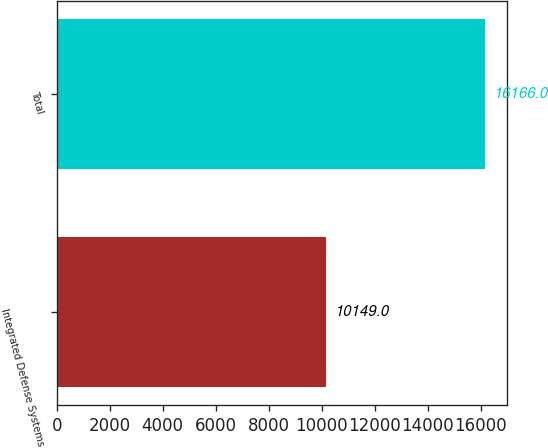<chart> <loc_0><loc_0><loc_500><loc_500><bar_chart><fcel>Integrated Defense Systems<fcel>Total<nl><fcel>10149<fcel>16166<nl></chart> 